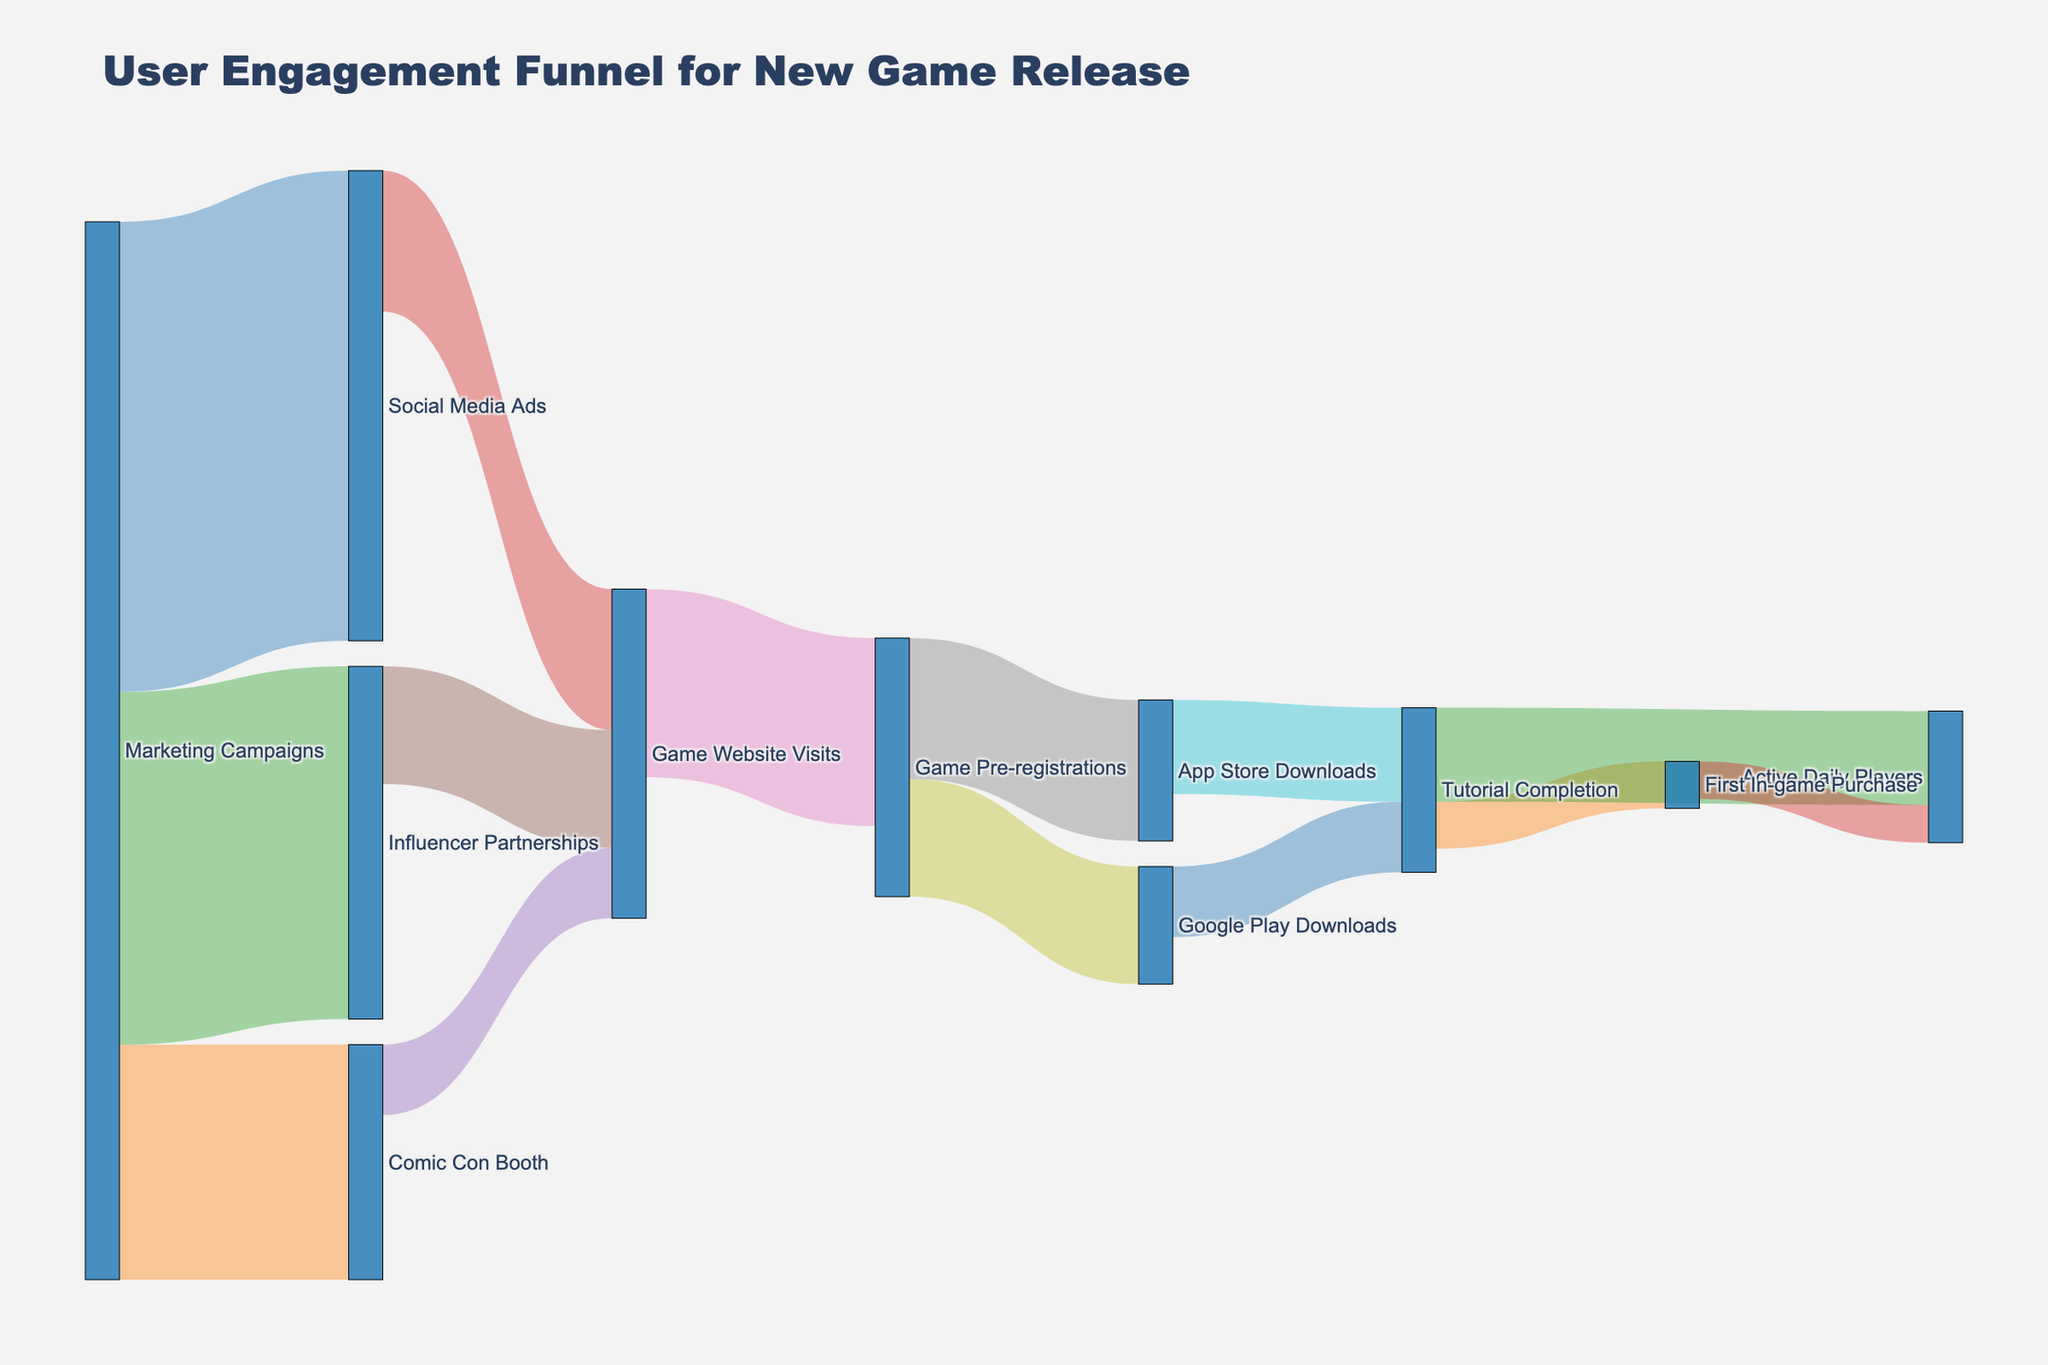What is the title of the diagram? The title can be found at the top of the diagram, usually providing a clear summary of what the diagram represents.
Answer: User Engagement Funnel for New Game Release Which marketing campaign channel had the highest initial number of engagements? The values next to each marketing campaign channel show the initial number of engagements. The highest number of engagements is seen next to Social Media Ads.
Answer: Social Media Ads What is the total number of Game Website Visits from all marketing channels combined? To find the total number of Game Website Visits, sum the values flowing into Game Website Visits from all marketing channels: 30000 (from Social Media Ads) + 15000 (from Comic Con Booth) + 25000 (from Influencer Partnerships). 30000 + 15000 + 25000 = 70000
Answer: 70000 How many users completed the Tutorial for the game across both app stores? The value shown for App Store Downloads to Tutorial Completion and Google Play Downloads to Tutorial Completion will be added. 20000 (App Store Downloads) + 15000 (Google Play Downloads) = 35000
Answer: 35000 What is the difference in the number of users who made a First In-game Purchase and those who became Active Daily Players after completing the Tutorial? The number of users who made a First In-game Purchase is 10000 and the number of users who became Active Daily Players from Tutorial Completion is 20000. The difference is calculated by subtracting the first value from the second value: 20000 - 10000 = 10000
Answer: 10000 Which stage shows the highest drop-off in user numbers? By comparing the values decrease at each stage, the largest drop-off is seen from Game Pre-registrations (40000) to App Store Downloads (30000) + Google Play Downloads (25000) which together sum to 55000. However, comparing the decrease from Game Website Visits to Game Pre-registrations, which drops from 70000 to 40000 is higher. Therefore, 70000 to 40000 indicates a 30000 drop-off.
Answer: From Game Website Visits to Game Pre-registrations How many users transitioned from Influencer Partnerships to App Store Downloads? Users from Influencer Partnerships first visit the Game Website and then pre-register before downloading from the App Store. This flow is given by summing the transitions from Influencer Partnerships to Website and from Pre-registrations to App Store: 25000 to Website and a portion of pre-registrations to App Store, calculating 25000 contributing to App Store within the total pre-registrations. Given 30000 to App Store from pre-registrations, a part of Influencer results in the logical flow to App characteristics, which indirectly connects two stages via Website path.
Answer: Indirectly 7500 (proportioned path) Compare the number of users who visit the game website via Comic Con Booth and Social Media Ads. The value for Game Website Visits via Comic Con Booth is 15000 and from Social Media Ads is 30000. The value from Social Media Ads is greater.
Answer: Social Media Ads How many more Active Daily Players are there than First In-game Purchases? The number of Active Daily Players from Tutorial Completion is 20000 and from First In-game Purchase is 8000. The difference is calculated by subtracting the First In-game Purchases from total Active Daily Players: 20000 - 8000 = 12000
Answer: 12000 